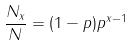<formula> <loc_0><loc_0><loc_500><loc_500>\frac { N _ { x } } { N } = ( 1 - p ) p ^ { x - 1 }</formula> 